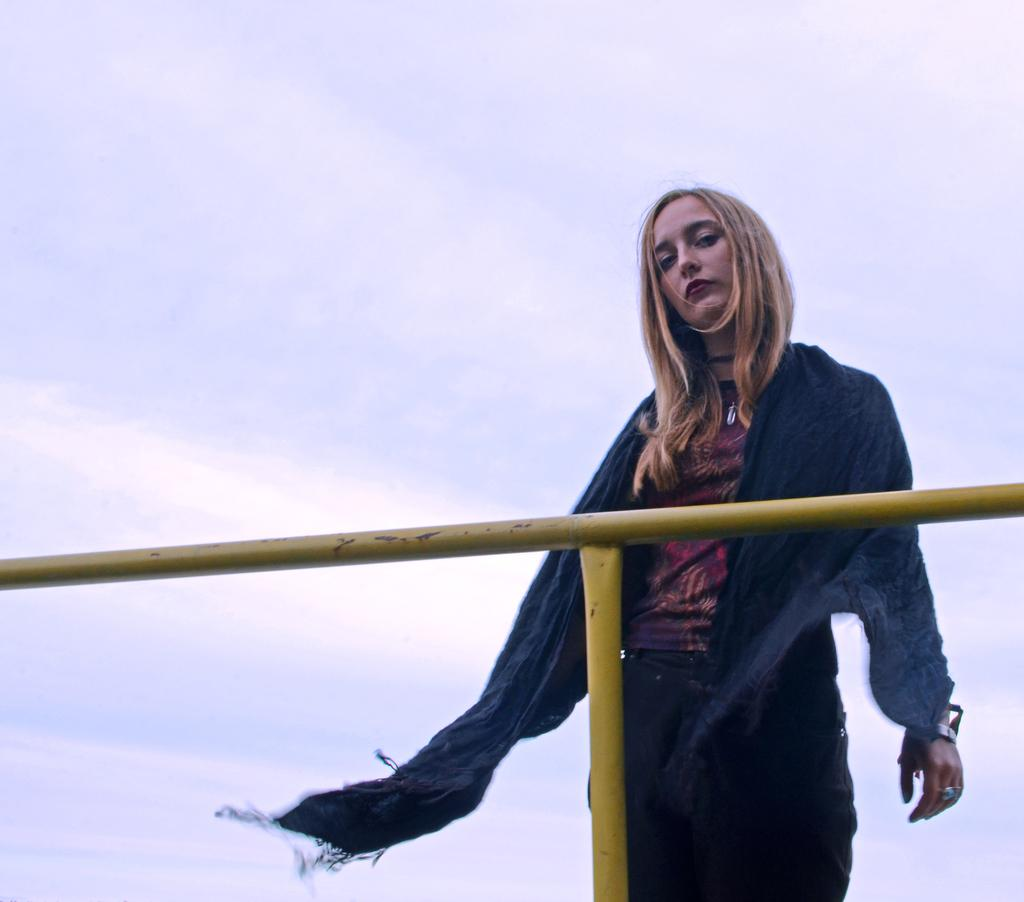What is located in the foreground of the image? There is a woman standing and a pole in the foreground of the image. Can you describe the woman's position in the image? The woman is standing in the foreground of the image. What can be seen in the background of the image? The sky is visible in the background of the image. What type of pump can be seen near the woman's toe in the image? There is no pump or reference to a woman's toe present in the image. 